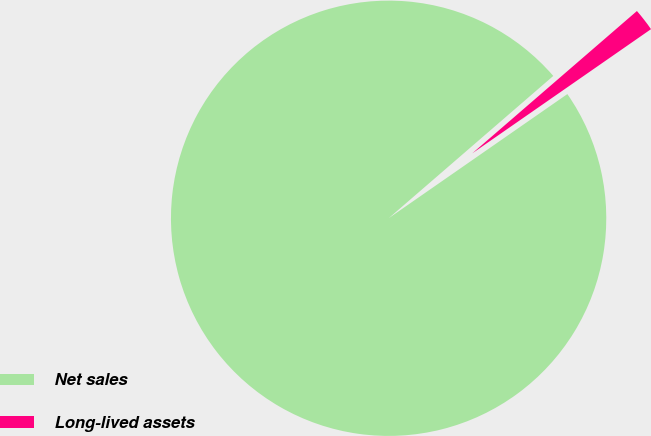Convert chart to OTSL. <chart><loc_0><loc_0><loc_500><loc_500><pie_chart><fcel>Net sales<fcel>Long-lived assets<nl><fcel>98.32%<fcel>1.68%<nl></chart> 